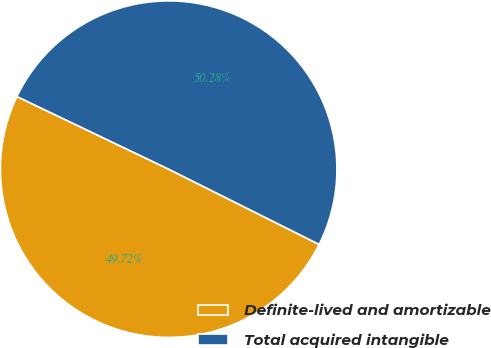Convert chart. <chart><loc_0><loc_0><loc_500><loc_500><pie_chart><fcel>Definite-lived and amortizable<fcel>Total acquired intangible<nl><fcel>49.72%<fcel>50.28%<nl></chart> 